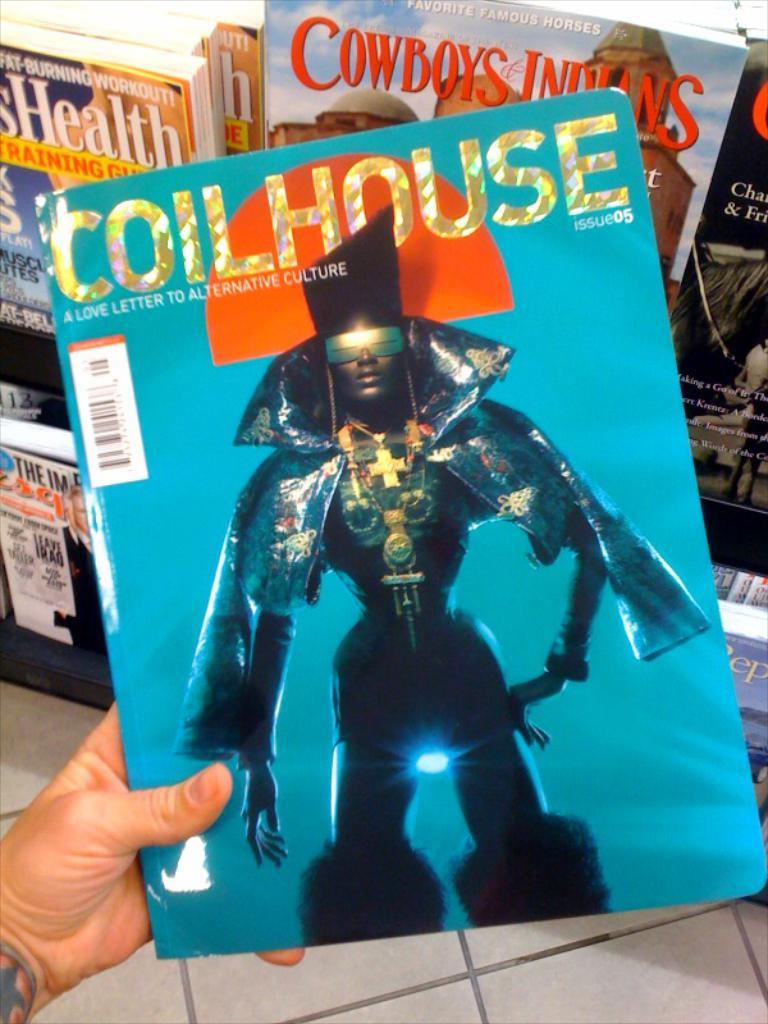<image>
Render a clear and concise summary of the photo. Someone is holding a magazine with the title Coilhouse. 